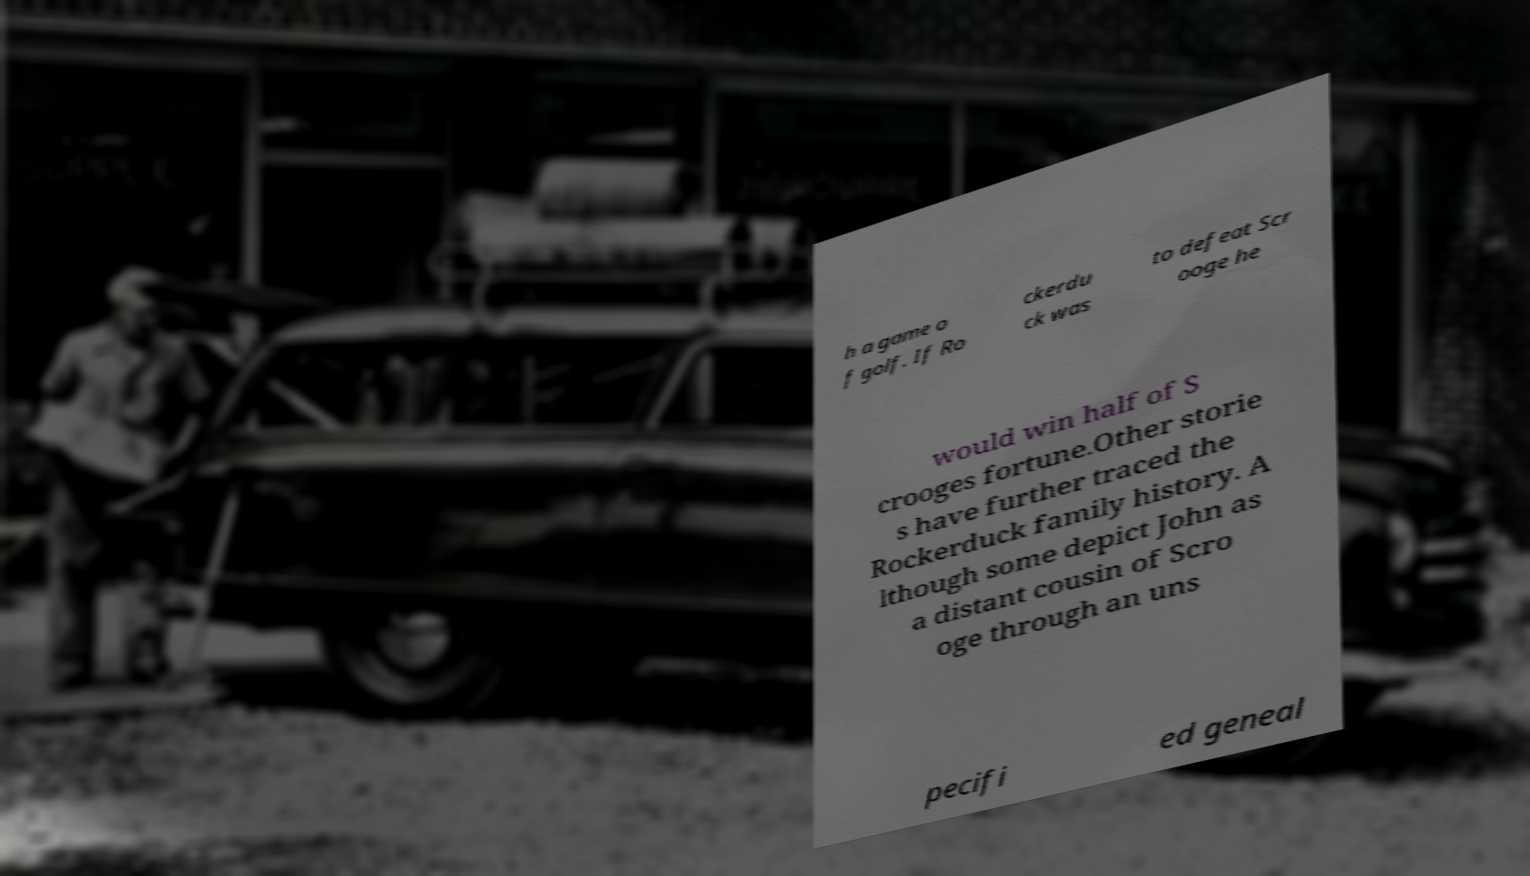Could you assist in decoding the text presented in this image and type it out clearly? h a game o f golf. If Ro ckerdu ck was to defeat Scr ooge he would win half of S crooges fortune.Other storie s have further traced the Rockerduck family history. A lthough some depict John as a distant cousin of Scro oge through an uns pecifi ed geneal 